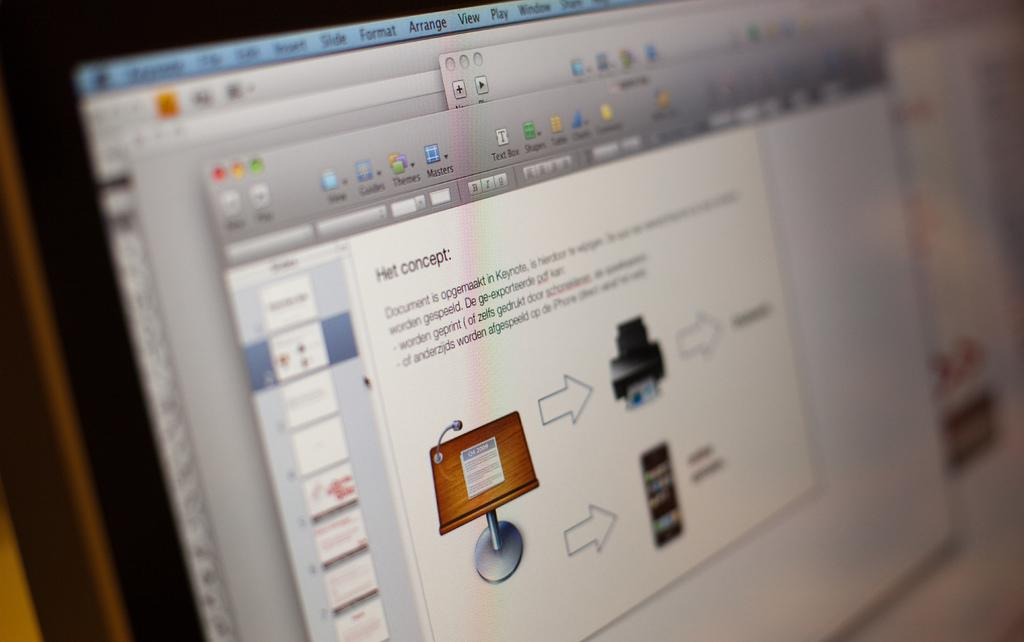<image>
Render a clear and concise summary of the photo. Computer screen showing different HET concepts and explanation. 